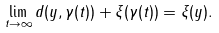Convert formula to latex. <formula><loc_0><loc_0><loc_500><loc_500>\lim _ { t \to \infty } d ( y , \gamma ( t ) ) + \xi ( \gamma ( t ) ) = \xi ( y ) .</formula> 